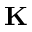<formula> <loc_0><loc_0><loc_500><loc_500>K</formula> 